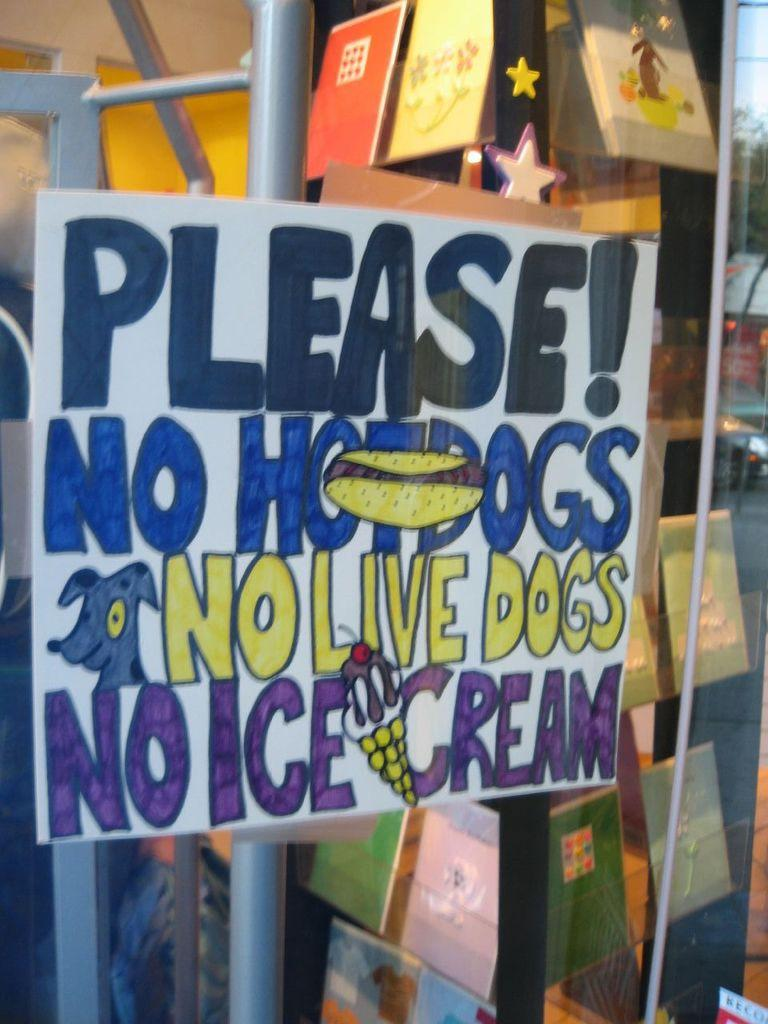<image>
Share a concise interpretation of the image provided. Large sign on a store that says "Please! No hotdogs No Live Dogs No Ice Cream". 